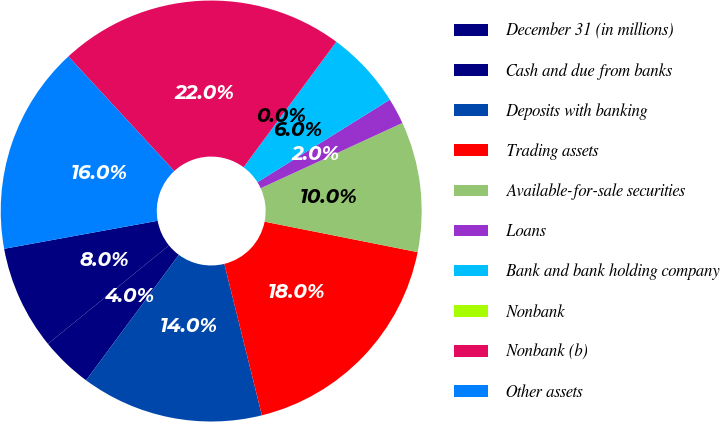Convert chart to OTSL. <chart><loc_0><loc_0><loc_500><loc_500><pie_chart><fcel>December 31 (in millions)<fcel>Cash and due from banks<fcel>Deposits with banking<fcel>Trading assets<fcel>Available-for-sale securities<fcel>Loans<fcel>Bank and bank holding company<fcel>Nonbank<fcel>Nonbank (b)<fcel>Other assets<nl><fcel>8.0%<fcel>4.0%<fcel>14.0%<fcel>18.0%<fcel>10.0%<fcel>2.0%<fcel>6.0%<fcel>0.0%<fcel>22.0%<fcel>16.0%<nl></chart> 